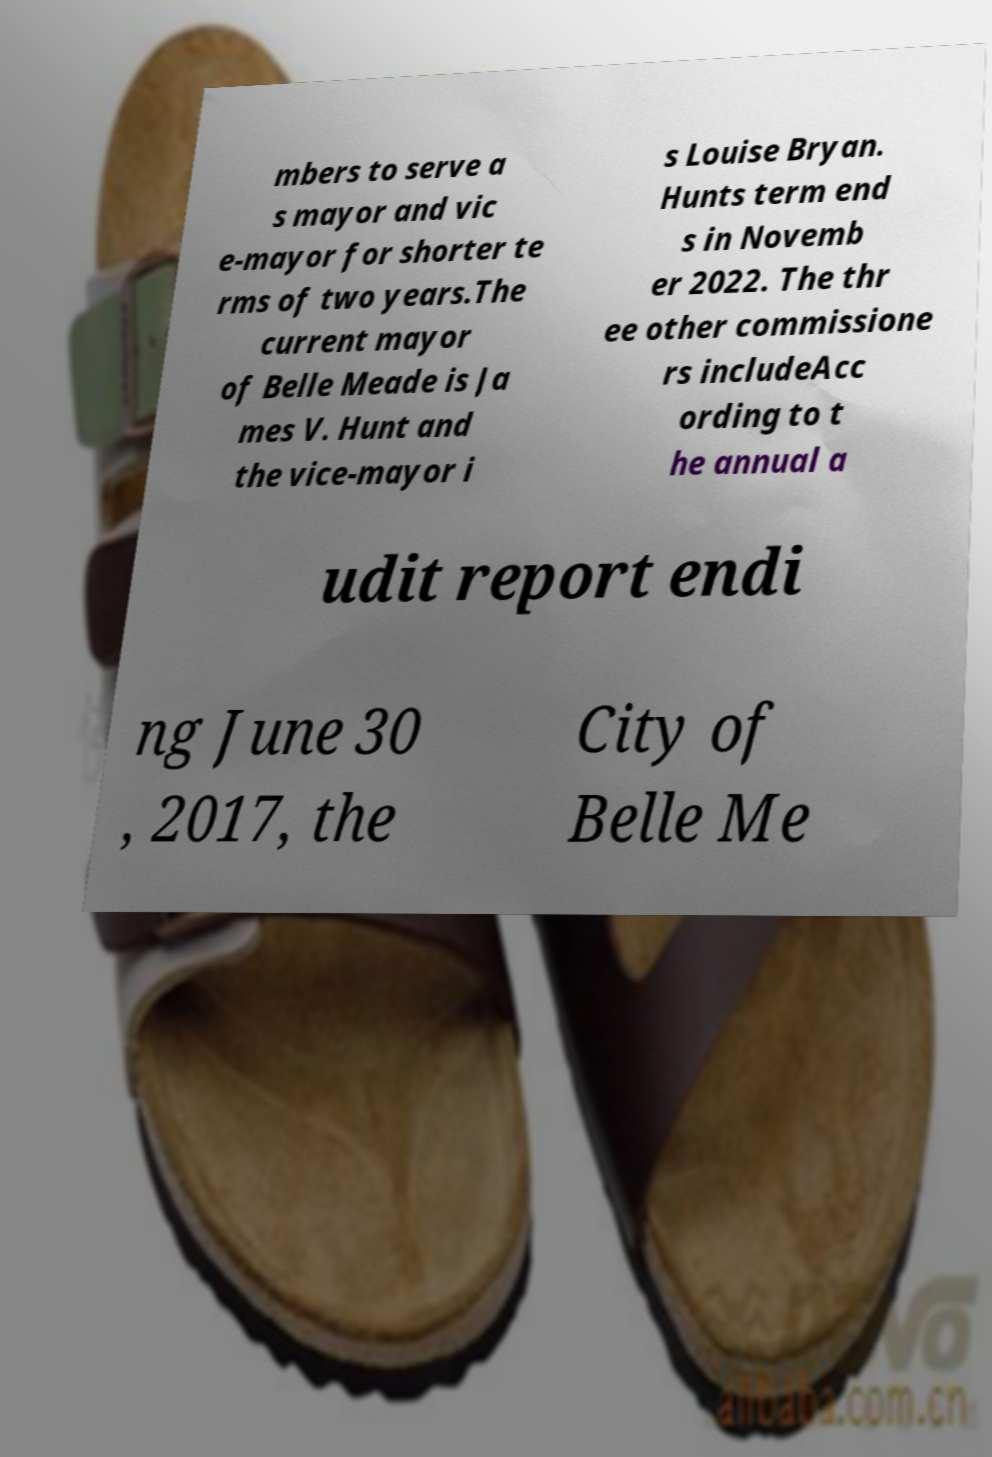Please read and relay the text visible in this image. What does it say? mbers to serve a s mayor and vic e-mayor for shorter te rms of two years.The current mayor of Belle Meade is Ja mes V. Hunt and the vice-mayor i s Louise Bryan. Hunts term end s in Novemb er 2022. The thr ee other commissione rs includeAcc ording to t he annual a udit report endi ng June 30 , 2017, the City of Belle Me 